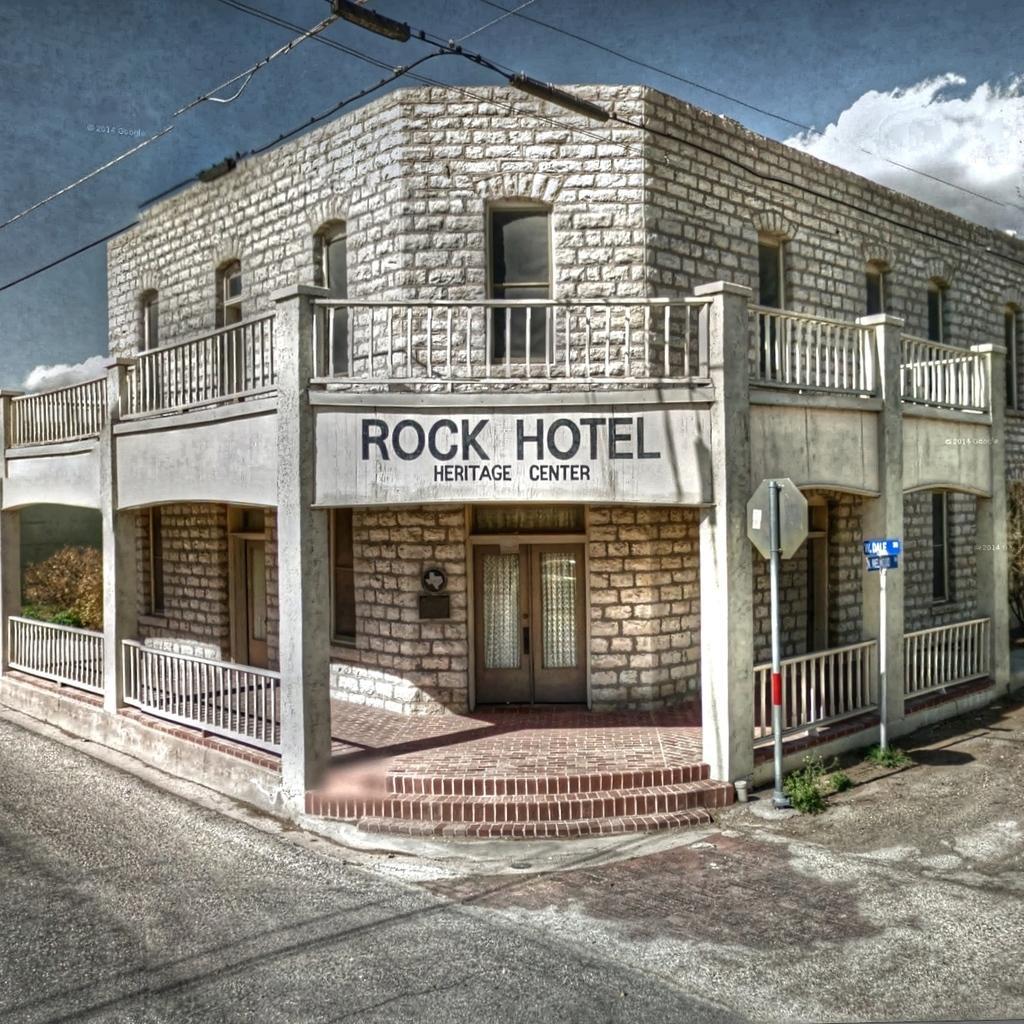Can you describe this image briefly? In this image there is a road in the background there is a building, poles, wires and a sky. 